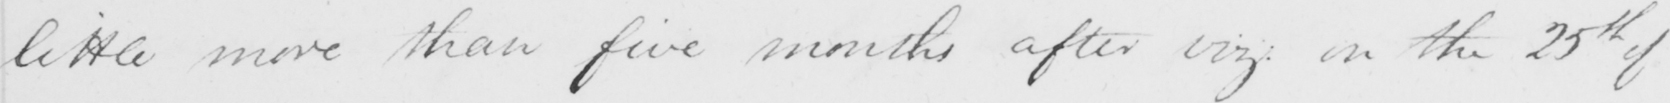Can you tell me what this handwritten text says? little more than five months after viz :  on the 25th of 